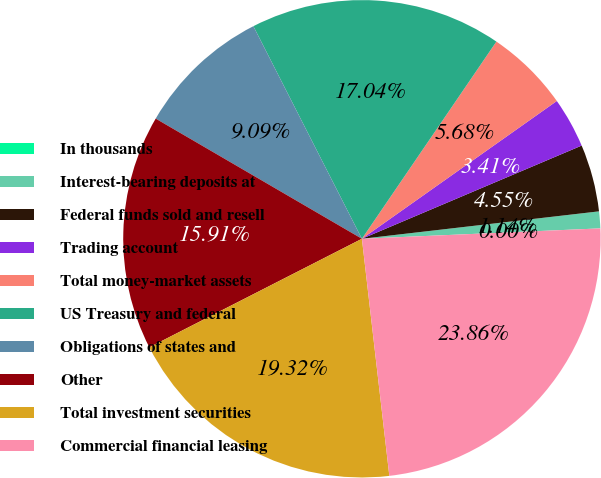<chart> <loc_0><loc_0><loc_500><loc_500><pie_chart><fcel>In thousands<fcel>Interest-bearing deposits at<fcel>Federal funds sold and resell<fcel>Trading account<fcel>Total money-market assets<fcel>US Treasury and federal<fcel>Obligations of states and<fcel>Other<fcel>Total investment securities<fcel>Commercial financial leasing<nl><fcel>0.0%<fcel>1.14%<fcel>4.55%<fcel>3.41%<fcel>5.68%<fcel>17.04%<fcel>9.09%<fcel>15.91%<fcel>19.32%<fcel>23.86%<nl></chart> 